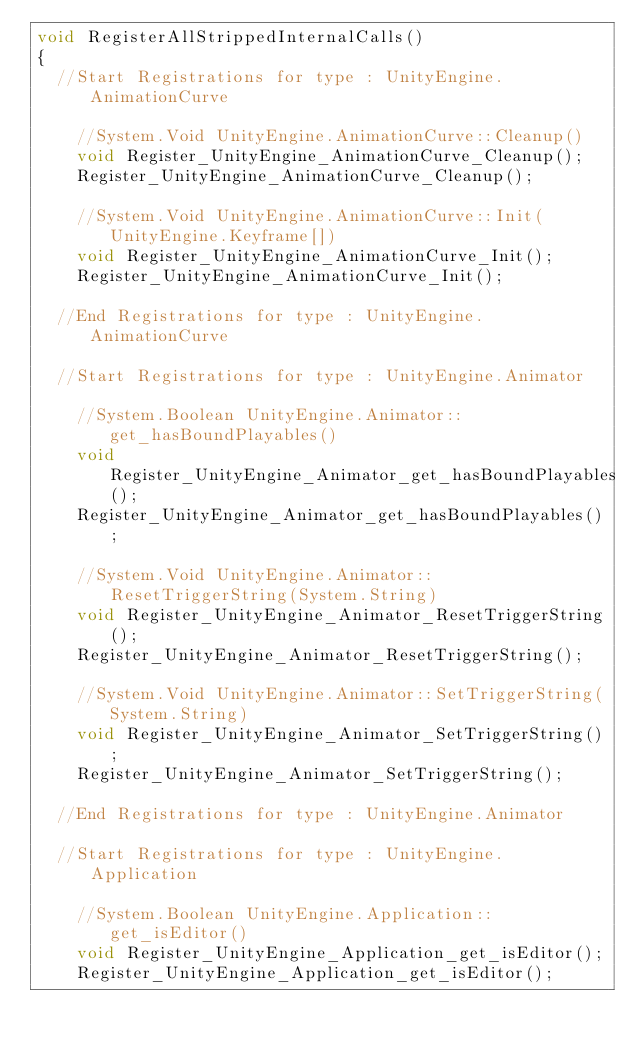<code> <loc_0><loc_0><loc_500><loc_500><_C++_>void RegisterAllStrippedInternalCalls()
{
	//Start Registrations for type : UnityEngine.AnimationCurve

		//System.Void UnityEngine.AnimationCurve::Cleanup()
		void Register_UnityEngine_AnimationCurve_Cleanup();
		Register_UnityEngine_AnimationCurve_Cleanup();

		//System.Void UnityEngine.AnimationCurve::Init(UnityEngine.Keyframe[])
		void Register_UnityEngine_AnimationCurve_Init();
		Register_UnityEngine_AnimationCurve_Init();

	//End Registrations for type : UnityEngine.AnimationCurve

	//Start Registrations for type : UnityEngine.Animator

		//System.Boolean UnityEngine.Animator::get_hasBoundPlayables()
		void Register_UnityEngine_Animator_get_hasBoundPlayables();
		Register_UnityEngine_Animator_get_hasBoundPlayables();

		//System.Void UnityEngine.Animator::ResetTriggerString(System.String)
		void Register_UnityEngine_Animator_ResetTriggerString();
		Register_UnityEngine_Animator_ResetTriggerString();

		//System.Void UnityEngine.Animator::SetTriggerString(System.String)
		void Register_UnityEngine_Animator_SetTriggerString();
		Register_UnityEngine_Animator_SetTriggerString();

	//End Registrations for type : UnityEngine.Animator

	//Start Registrations for type : UnityEngine.Application

		//System.Boolean UnityEngine.Application::get_isEditor()
		void Register_UnityEngine_Application_get_isEditor();
		Register_UnityEngine_Application_get_isEditor();
</code> 